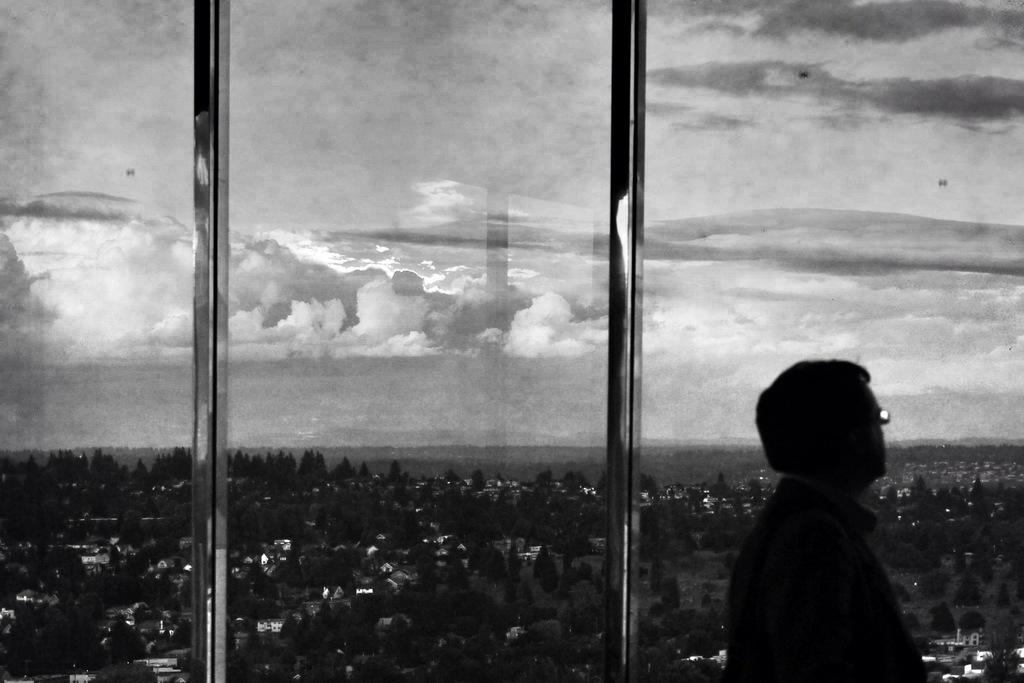Who or what is on the right side of the image? There is a person on the right side of the image. What can be seen in the background of the image? There are trees and buildings in the background of the image. What is visible in the sky in the image? Clouds are visible in the sky in the image. What type of feather can be seen on the sign in the image? There is no sign or feather present in the image. How many sticks are being used by the person in the image? There is no indication of sticks being used by the person in the image. 